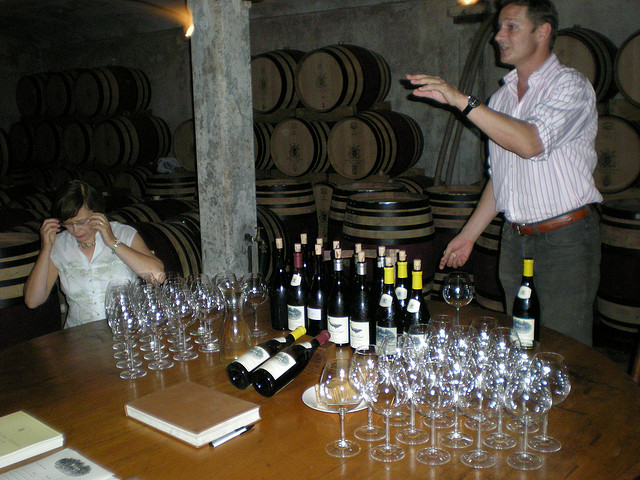What kind of wood is used to make the barrels in the background? The barrels in the background are traditionally made from oak, which is favored in winemaking for its strength and its ability to impart favorable qualities like tannins and flavor compounds to the wine during the aging process. 